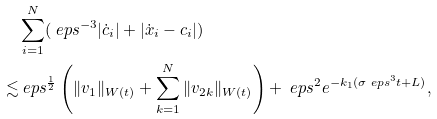Convert formula to latex. <formula><loc_0><loc_0><loc_500><loc_500>& \sum _ { i = 1 } ^ { N } ( \ e p s ^ { - 3 } | \dot { c } _ { i } | + | \dot { x } _ { i } - c _ { i } | ) \\ \lesssim & \ e p s ^ { \frac { 1 } { 2 } } \left ( \| v _ { 1 } \| _ { W ( t ) } + \sum _ { k = 1 } ^ { N } \| v _ { 2 k } \| _ { W ( t ) } \right ) + \ e p s ^ { 2 } e ^ { - k _ { 1 } ( \sigma \ e p s ^ { 3 } t + L ) } ,</formula> 